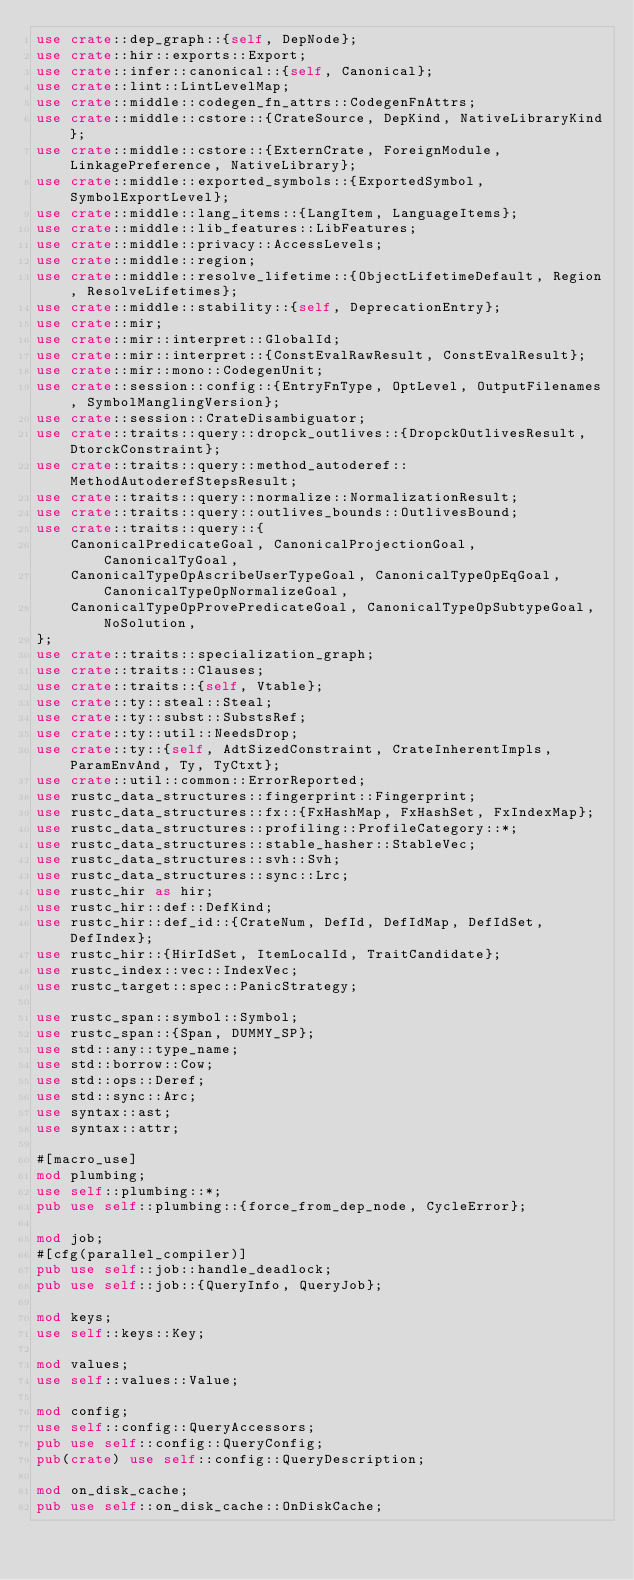<code> <loc_0><loc_0><loc_500><loc_500><_Rust_>use crate::dep_graph::{self, DepNode};
use crate::hir::exports::Export;
use crate::infer::canonical::{self, Canonical};
use crate::lint::LintLevelMap;
use crate::middle::codegen_fn_attrs::CodegenFnAttrs;
use crate::middle::cstore::{CrateSource, DepKind, NativeLibraryKind};
use crate::middle::cstore::{ExternCrate, ForeignModule, LinkagePreference, NativeLibrary};
use crate::middle::exported_symbols::{ExportedSymbol, SymbolExportLevel};
use crate::middle::lang_items::{LangItem, LanguageItems};
use crate::middle::lib_features::LibFeatures;
use crate::middle::privacy::AccessLevels;
use crate::middle::region;
use crate::middle::resolve_lifetime::{ObjectLifetimeDefault, Region, ResolveLifetimes};
use crate::middle::stability::{self, DeprecationEntry};
use crate::mir;
use crate::mir::interpret::GlobalId;
use crate::mir::interpret::{ConstEvalRawResult, ConstEvalResult};
use crate::mir::mono::CodegenUnit;
use crate::session::config::{EntryFnType, OptLevel, OutputFilenames, SymbolManglingVersion};
use crate::session::CrateDisambiguator;
use crate::traits::query::dropck_outlives::{DropckOutlivesResult, DtorckConstraint};
use crate::traits::query::method_autoderef::MethodAutoderefStepsResult;
use crate::traits::query::normalize::NormalizationResult;
use crate::traits::query::outlives_bounds::OutlivesBound;
use crate::traits::query::{
    CanonicalPredicateGoal, CanonicalProjectionGoal, CanonicalTyGoal,
    CanonicalTypeOpAscribeUserTypeGoal, CanonicalTypeOpEqGoal, CanonicalTypeOpNormalizeGoal,
    CanonicalTypeOpProvePredicateGoal, CanonicalTypeOpSubtypeGoal, NoSolution,
};
use crate::traits::specialization_graph;
use crate::traits::Clauses;
use crate::traits::{self, Vtable};
use crate::ty::steal::Steal;
use crate::ty::subst::SubstsRef;
use crate::ty::util::NeedsDrop;
use crate::ty::{self, AdtSizedConstraint, CrateInherentImpls, ParamEnvAnd, Ty, TyCtxt};
use crate::util::common::ErrorReported;
use rustc_data_structures::fingerprint::Fingerprint;
use rustc_data_structures::fx::{FxHashMap, FxHashSet, FxIndexMap};
use rustc_data_structures::profiling::ProfileCategory::*;
use rustc_data_structures::stable_hasher::StableVec;
use rustc_data_structures::svh::Svh;
use rustc_data_structures::sync::Lrc;
use rustc_hir as hir;
use rustc_hir::def::DefKind;
use rustc_hir::def_id::{CrateNum, DefId, DefIdMap, DefIdSet, DefIndex};
use rustc_hir::{HirIdSet, ItemLocalId, TraitCandidate};
use rustc_index::vec::IndexVec;
use rustc_target::spec::PanicStrategy;

use rustc_span::symbol::Symbol;
use rustc_span::{Span, DUMMY_SP};
use std::any::type_name;
use std::borrow::Cow;
use std::ops::Deref;
use std::sync::Arc;
use syntax::ast;
use syntax::attr;

#[macro_use]
mod plumbing;
use self::plumbing::*;
pub use self::plumbing::{force_from_dep_node, CycleError};

mod job;
#[cfg(parallel_compiler)]
pub use self::job::handle_deadlock;
pub use self::job::{QueryInfo, QueryJob};

mod keys;
use self::keys::Key;

mod values;
use self::values::Value;

mod config;
use self::config::QueryAccessors;
pub use self::config::QueryConfig;
pub(crate) use self::config::QueryDescription;

mod on_disk_cache;
pub use self::on_disk_cache::OnDiskCache;
</code> 